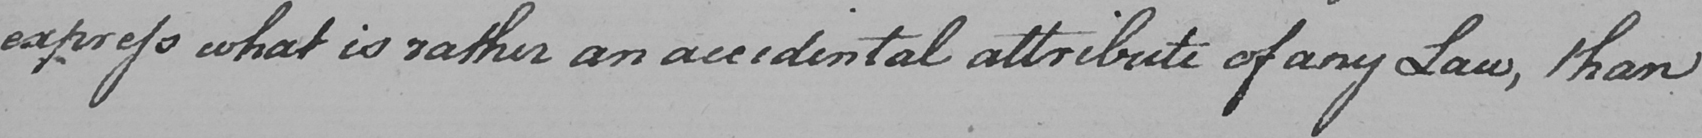What is written in this line of handwriting? express what is rather an accidental attribute of any Law , than 